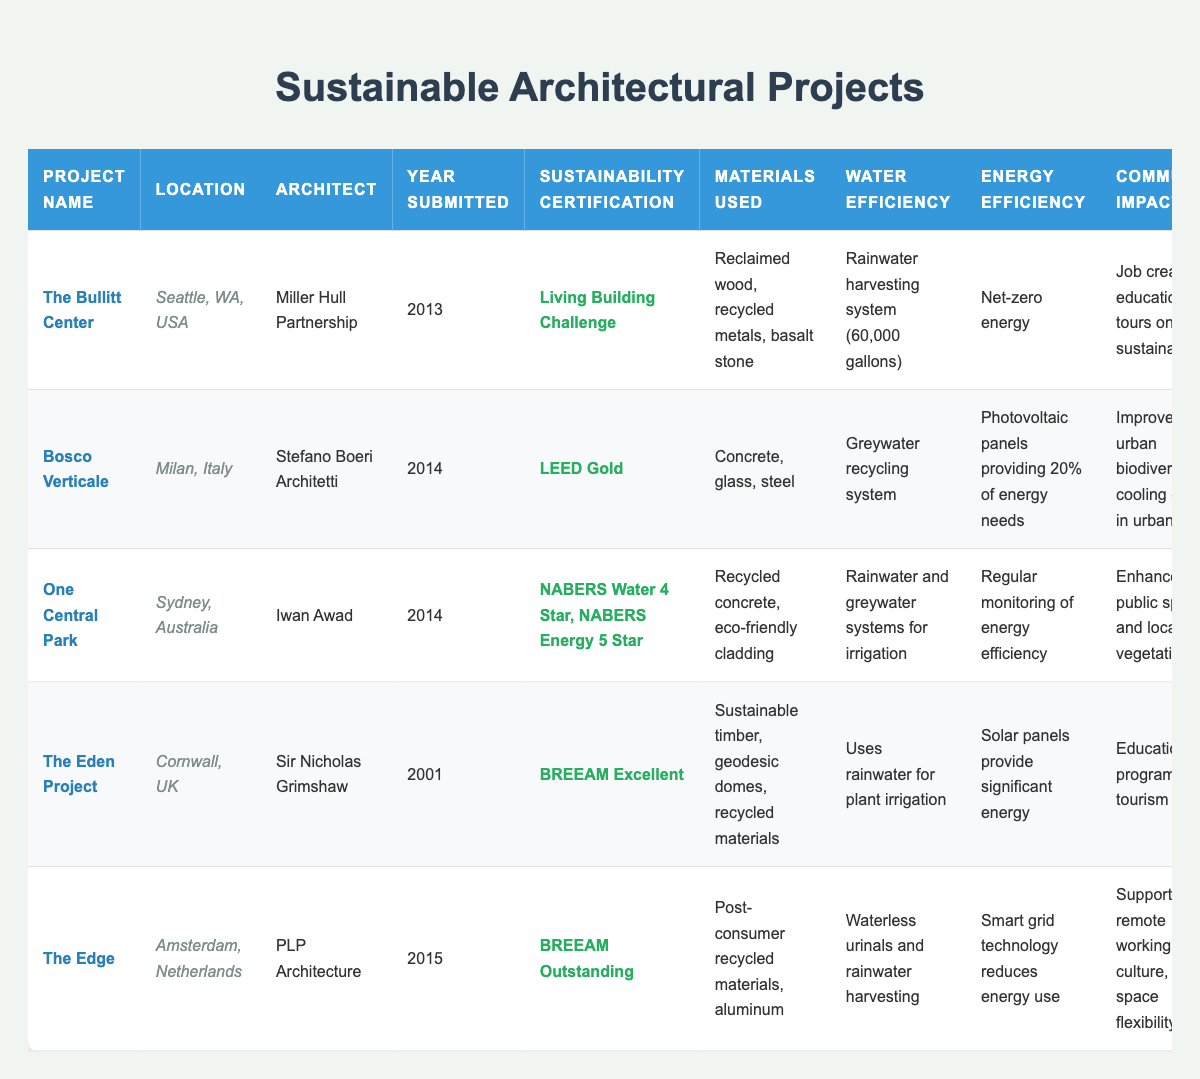What is the sustainability certification of "The Bullitt Center"? The table lists the sustainability certification under the column "Sustainability Certification" for "The Bullitt Center," which shows "Living Building Challenge."
Answer: Living Building Challenge Which project was architected by Sir Nicholas Grimshaw? By checking the "Architect" column, we can see that "The Eden Project" is listed next to Sir Nicholas Grimshaw.
Answer: The Eden Project How many projects were submitted in the year 2014? The table indicates that there are three projects with the year submitted marked as 2014: "Bosco Verticale," "One Central Park," and "The Bullitt Center." Therefore, the count is 3.
Answer: 3 What materials are used in "The Edge"? Looking at the "Materials Used" column for "The Edge," it specifies "Post-consumer recycled materials, aluminum."
Answer: Post-consumer recycled materials, aluminum Is "One Central Park" certified under LEED? By reviewing the certification of "One Central Park," the table indicates it is certified under "NABERS Water 4 Star, NABERS Energy 5 Star," not LEED. Hence the answer is no.
Answer: No Which project has the largest water efficiency system mentioned? Evaluating the "Water Efficiency" column, "The Bullitt Center" notes a rainwater harvesting system of 60,000 gallons, which appears to be the largest.
Answer: The Bullitt Center Are all projects located in different countries? Checking the "Location" column, each project is listed in a different country: USA, Italy, Australia, UK, Netherlands. Hence, the answer is yes.
Answer: Yes What is the average year of submission for the projects listed? The submission years are: 2013, 2014, 2014, 2001, and 2015. Adding these yields 2013 + 2014 + 2014 + 2001 + 2015 = 10071. Dividing this by 5, the average year is 2014.2, which can be approximated to 2014.
Answer: 2014 Which project contributed to urban biodiversity? The table states that "Bosco Verticale" improved urban biodiversity, solely identifying this project for that impact.
Answer: Bosco Verticale What is the common energy efficiency feature across most projects? By assessing the "Energy Efficiency" column, the common feature across multiple projects involves renewable energy usage, such as solar panels, smart grids, and monitoring systems for efficiency.
Answer: Renewable energy usage 